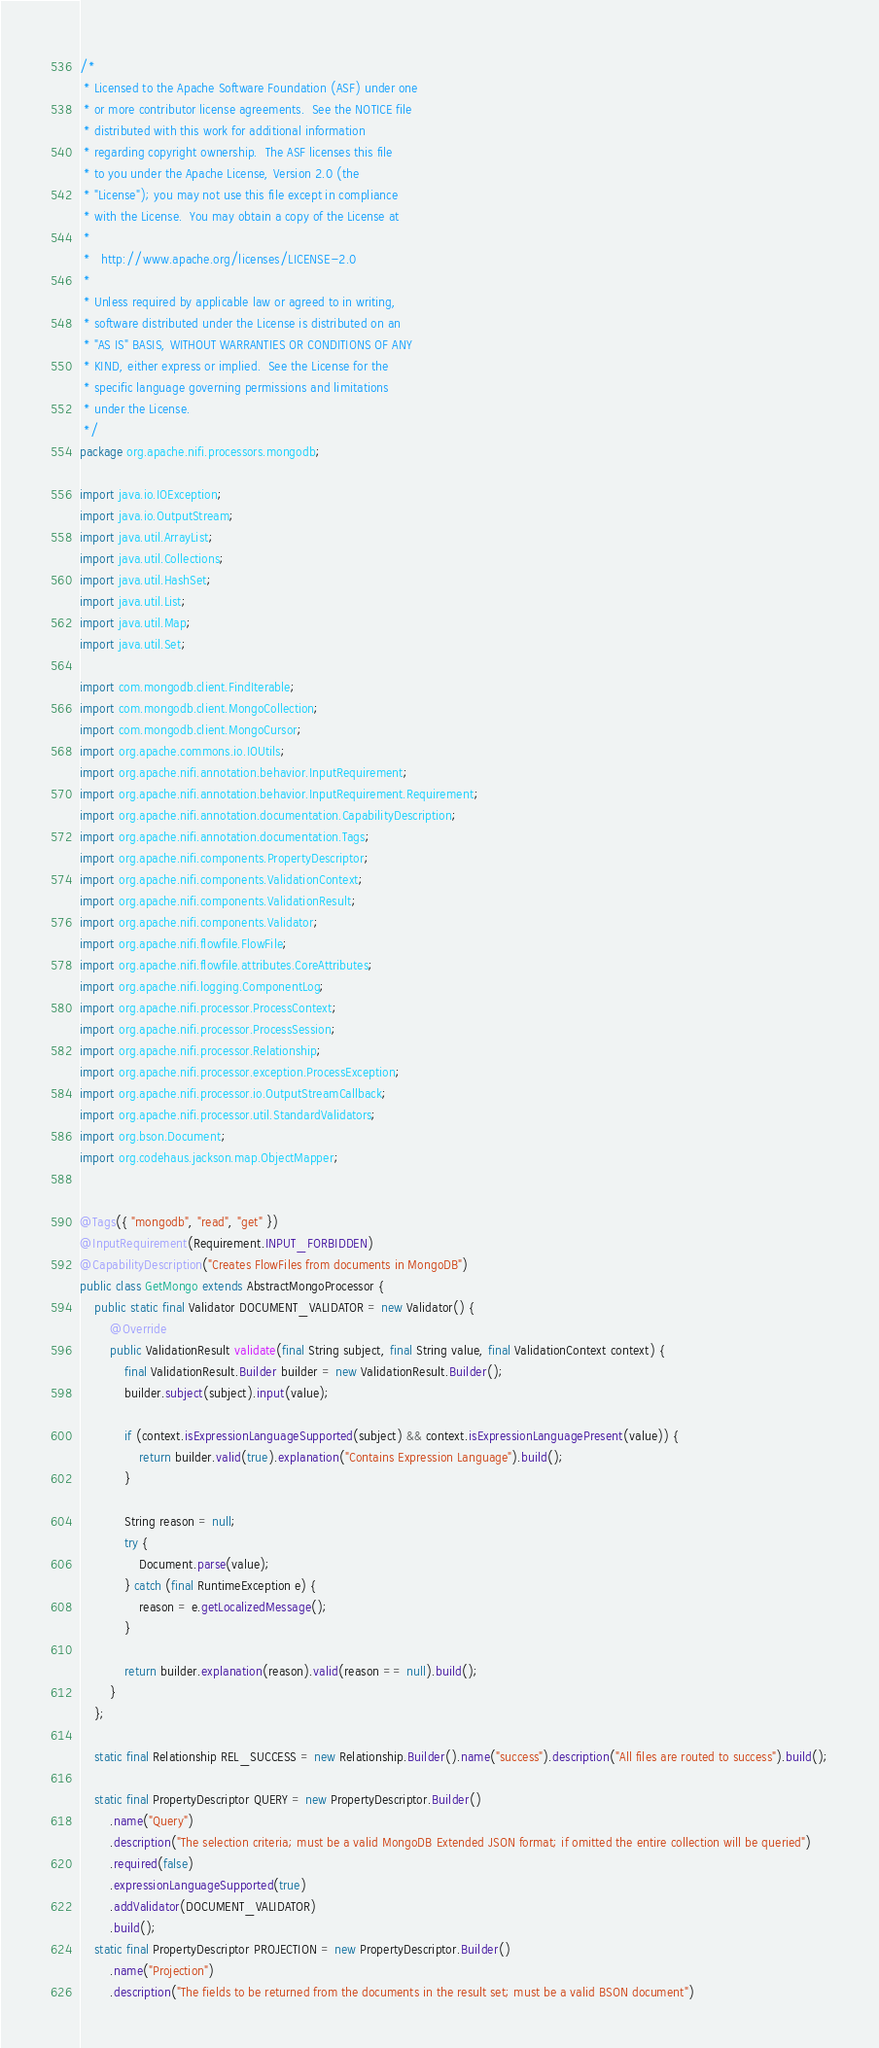<code> <loc_0><loc_0><loc_500><loc_500><_Java_>/*
 * Licensed to the Apache Software Foundation (ASF) under one
 * or more contributor license agreements.  See the NOTICE file
 * distributed with this work for additional information
 * regarding copyright ownership.  The ASF licenses this file
 * to you under the Apache License, Version 2.0 (the
 * "License"); you may not use this file except in compliance
 * with the License.  You may obtain a copy of the License at
 *
 *   http://www.apache.org/licenses/LICENSE-2.0
 *
 * Unless required by applicable law or agreed to in writing,
 * software distributed under the License is distributed on an
 * "AS IS" BASIS, WITHOUT WARRANTIES OR CONDITIONS OF ANY
 * KIND, either express or implied.  See the License for the
 * specific language governing permissions and limitations
 * under the License.
 */
package org.apache.nifi.processors.mongodb;

import java.io.IOException;
import java.io.OutputStream;
import java.util.ArrayList;
import java.util.Collections;
import java.util.HashSet;
import java.util.List;
import java.util.Map;
import java.util.Set;

import com.mongodb.client.FindIterable;
import com.mongodb.client.MongoCollection;
import com.mongodb.client.MongoCursor;
import org.apache.commons.io.IOUtils;
import org.apache.nifi.annotation.behavior.InputRequirement;
import org.apache.nifi.annotation.behavior.InputRequirement.Requirement;
import org.apache.nifi.annotation.documentation.CapabilityDescription;
import org.apache.nifi.annotation.documentation.Tags;
import org.apache.nifi.components.PropertyDescriptor;
import org.apache.nifi.components.ValidationContext;
import org.apache.nifi.components.ValidationResult;
import org.apache.nifi.components.Validator;
import org.apache.nifi.flowfile.FlowFile;
import org.apache.nifi.flowfile.attributes.CoreAttributes;
import org.apache.nifi.logging.ComponentLog;
import org.apache.nifi.processor.ProcessContext;
import org.apache.nifi.processor.ProcessSession;
import org.apache.nifi.processor.Relationship;
import org.apache.nifi.processor.exception.ProcessException;
import org.apache.nifi.processor.io.OutputStreamCallback;
import org.apache.nifi.processor.util.StandardValidators;
import org.bson.Document;
import org.codehaus.jackson.map.ObjectMapper;


@Tags({ "mongodb", "read", "get" })
@InputRequirement(Requirement.INPUT_FORBIDDEN)
@CapabilityDescription("Creates FlowFiles from documents in MongoDB")
public class GetMongo extends AbstractMongoProcessor {
    public static final Validator DOCUMENT_VALIDATOR = new Validator() {
        @Override
        public ValidationResult validate(final String subject, final String value, final ValidationContext context) {
            final ValidationResult.Builder builder = new ValidationResult.Builder();
            builder.subject(subject).input(value);

            if (context.isExpressionLanguageSupported(subject) && context.isExpressionLanguagePresent(value)) {
                return builder.valid(true).explanation("Contains Expression Language").build();
            }

            String reason = null;
            try {
                Document.parse(value);
            } catch (final RuntimeException e) {
                reason = e.getLocalizedMessage();
            }

            return builder.explanation(reason).valid(reason == null).build();
        }
    };

    static final Relationship REL_SUCCESS = new Relationship.Builder().name("success").description("All files are routed to success").build();

    static final PropertyDescriptor QUERY = new PropertyDescriptor.Builder()
        .name("Query")
        .description("The selection criteria; must be a valid MongoDB Extended JSON format; if omitted the entire collection will be queried")
        .required(false)
        .expressionLanguageSupported(true)
        .addValidator(DOCUMENT_VALIDATOR)
        .build();
    static final PropertyDescriptor PROJECTION = new PropertyDescriptor.Builder()
        .name("Projection")
        .description("The fields to be returned from the documents in the result set; must be a valid BSON document")</code> 